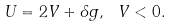Convert formula to latex. <formula><loc_0><loc_0><loc_500><loc_500>U = 2 V + \delta g , \ V < 0 .</formula> 